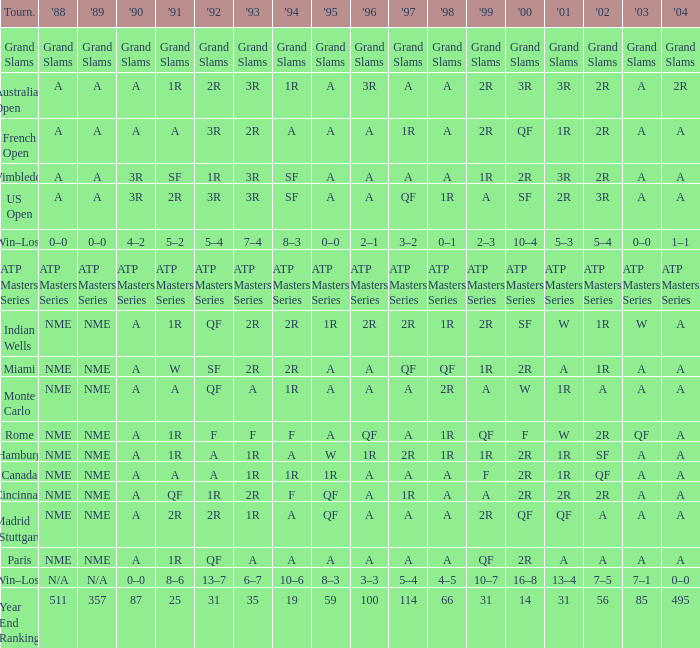What shows for 1995 when 1996 shows grand slams? Grand Slams. Write the full table. {'header': ['Tourn.', "'88", "'89", "'90", "'91", "'92", "'93", "'94", "'95", "'96", "'97", "'98", "'99", "'00", "'01", "'02", "'03", "'04"], 'rows': [['Grand Slams', 'Grand Slams', 'Grand Slams', 'Grand Slams', 'Grand Slams', 'Grand Slams', 'Grand Slams', 'Grand Slams', 'Grand Slams', 'Grand Slams', 'Grand Slams', 'Grand Slams', 'Grand Slams', 'Grand Slams', 'Grand Slams', 'Grand Slams', 'Grand Slams', 'Grand Slams'], ['Australian Open', 'A', 'A', 'A', '1R', '2R', '3R', '1R', 'A', '3R', 'A', 'A', '2R', '3R', '3R', '2R', 'A', '2R'], ['French Open', 'A', 'A', 'A', 'A', '3R', '2R', 'A', 'A', 'A', '1R', 'A', '2R', 'QF', '1R', '2R', 'A', 'A'], ['Wimbledon', 'A', 'A', '3R', 'SF', '1R', '3R', 'SF', 'A', 'A', 'A', 'A', '1R', '2R', '3R', '2R', 'A', 'A'], ['US Open', 'A', 'A', '3R', '2R', '3R', '3R', 'SF', 'A', 'A', 'QF', '1R', 'A', 'SF', '2R', '3R', 'A', 'A'], ['Win–Loss', '0–0', '0–0', '4–2', '5–2', '5–4', '7–4', '8–3', '0–0', '2–1', '3–2', '0–1', '2–3', '10–4', '5–3', '5–4', '0–0', '1–1'], ['ATP Masters Series', 'ATP Masters Series', 'ATP Masters Series', 'ATP Masters Series', 'ATP Masters Series', 'ATP Masters Series', 'ATP Masters Series', 'ATP Masters Series', 'ATP Masters Series', 'ATP Masters Series', 'ATP Masters Series', 'ATP Masters Series', 'ATP Masters Series', 'ATP Masters Series', 'ATP Masters Series', 'ATP Masters Series', 'ATP Masters Series', 'ATP Masters Series'], ['Indian Wells', 'NME', 'NME', 'A', '1R', 'QF', '2R', '2R', '1R', '2R', '2R', '1R', '2R', 'SF', 'W', '1R', 'W', 'A'], ['Miami', 'NME', 'NME', 'A', 'W', 'SF', '2R', '2R', 'A', 'A', 'QF', 'QF', '1R', '2R', 'A', '1R', 'A', 'A'], ['Monte Carlo', 'NME', 'NME', 'A', 'A', 'QF', 'A', '1R', 'A', 'A', 'A', '2R', 'A', 'W', '1R', 'A', 'A', 'A'], ['Rome', 'NME', 'NME', 'A', '1R', 'F', 'F', 'F', 'A', 'QF', 'A', '1R', 'QF', 'F', 'W', '2R', 'QF', 'A'], ['Hamburg', 'NME', 'NME', 'A', '1R', 'A', '1R', 'A', 'W', '1R', '2R', '1R', '1R', '2R', '1R', 'SF', 'A', 'A'], ['Canada', 'NME', 'NME', 'A', 'A', 'A', '1R', '1R', '1R', 'A', 'A', 'A', 'F', '2R', '1R', 'QF', 'A', 'A'], ['Cincinnati', 'NME', 'NME', 'A', 'QF', '1R', '2R', 'F', 'QF', 'A', '1R', 'A', 'A', '2R', '2R', '2R', 'A', 'A'], ['Madrid (Stuttgart)', 'NME', 'NME', 'A', '2R', '2R', '1R', 'A', 'QF', 'A', 'A', 'A', '2R', 'QF', 'QF', 'A', 'A', 'A'], ['Paris', 'NME', 'NME', 'A', '1R', 'QF', 'A', 'A', 'A', 'A', 'A', 'A', 'QF', '2R', 'A', 'A', 'A', 'A'], ['Win–Loss', 'N/A', 'N/A', '0–0', '8–6', '13–7', '6–7', '10–6', '8–3', '3–3', '5–4', '4–5', '10–7', '16–8', '13–4', '7–5', '7–1', '0–0'], ['Year End Ranking', '511', '357', '87', '25', '31', '35', '19', '59', '100', '114', '66', '31', '14', '31', '56', '85', '495']]} 